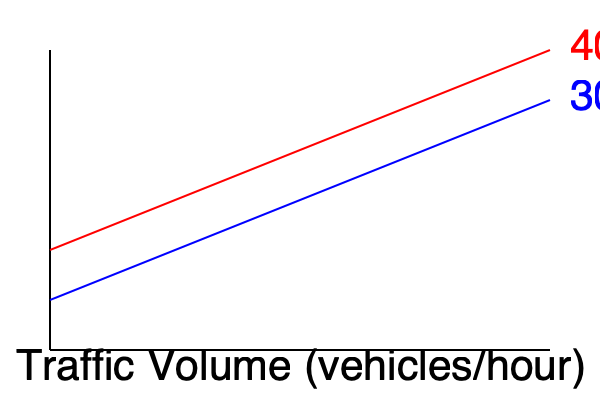Based on the graph showing recommended bike lane widths for different traffic volumes and speeds, what is the approximate difference in recommended bike lane width (in feet) between a 30 mph road and a 40 mph road, both with a traffic volume of 1000 vehicles per hour? To solve this problem, we need to follow these steps:

1. Locate the 1000 vehicles/hour point on the x-axis (Traffic Volume).
2. Find the corresponding y-values (Recommended Bike Lane Width) for both the 30 mph and 40 mph curves at this traffic volume.
3. Calculate the difference between these two y-values.

Step 1: The 1000 vehicles/hour point is approximately at the center of the x-axis.

Step 2: 
- For the 30 mph curve (blue), the y-value at 1000 vehicles/hour is approximately 5.5 feet.
- For the 40 mph curve (red), the y-value at 1000 vehicles/hour is approximately 7 feet.

Step 3: Calculate the difference:
$$ \text{Difference} = 7 \text{ feet} - 5.5 \text{ feet} = 1.5 \text{ feet} $$

Therefore, the approximate difference in recommended bike lane width between a 30 mph road and a 40 mph road, both with a traffic volume of 1000 vehicles per hour, is 1.5 feet.
Answer: 1.5 feet 